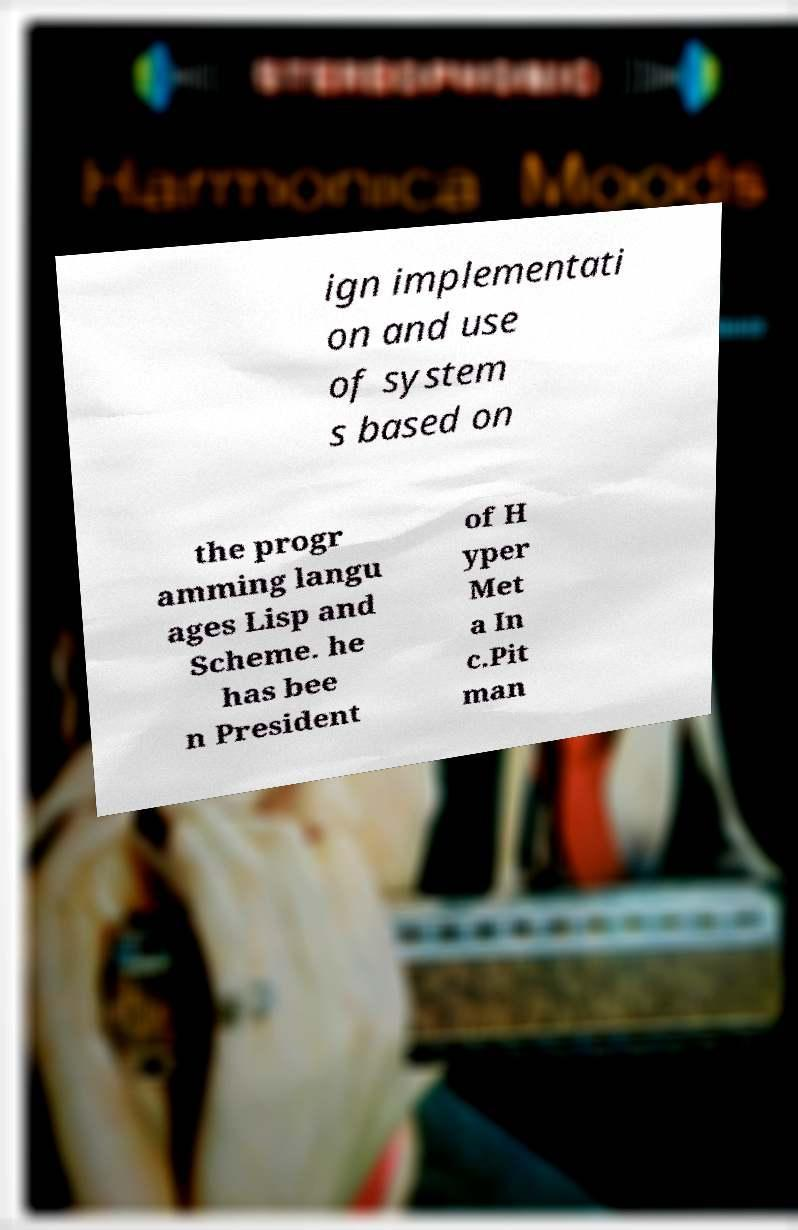For documentation purposes, I need the text within this image transcribed. Could you provide that? ign implementati on and use of system s based on the progr amming langu ages Lisp and Scheme. he has bee n President of H yper Met a In c.Pit man 